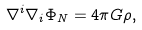Convert formula to latex. <formula><loc_0><loc_0><loc_500><loc_500>\nabla ^ { i } \nabla _ { i } \Phi _ { N } = 4 \pi G \rho ,</formula> 